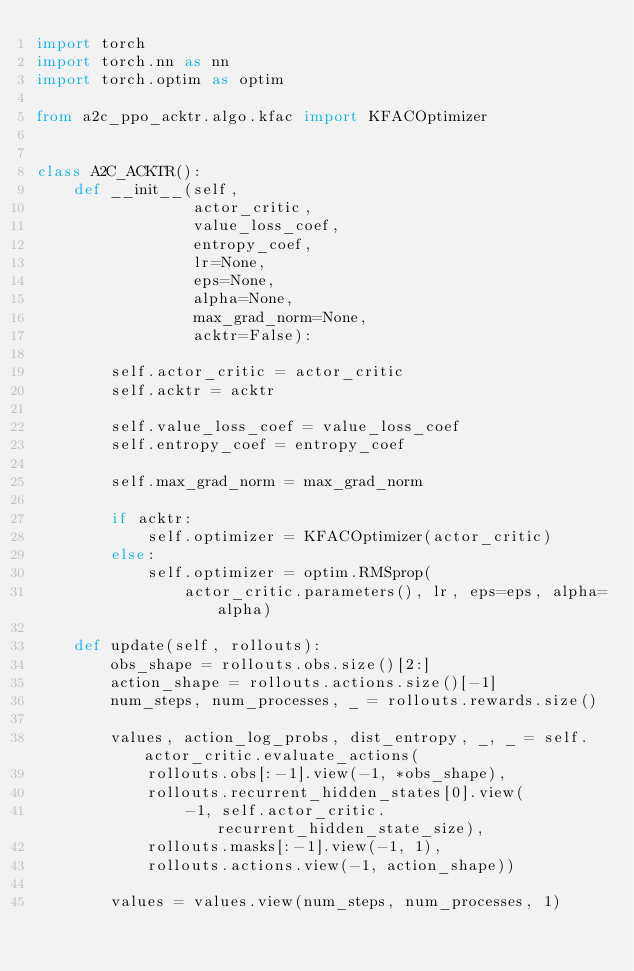<code> <loc_0><loc_0><loc_500><loc_500><_Python_>import torch
import torch.nn as nn
import torch.optim as optim

from a2c_ppo_acktr.algo.kfac import KFACOptimizer


class A2C_ACKTR():
    def __init__(self,
                 actor_critic,
                 value_loss_coef,
                 entropy_coef,
                 lr=None,
                 eps=None,
                 alpha=None,
                 max_grad_norm=None,
                 acktr=False):

        self.actor_critic = actor_critic
        self.acktr = acktr

        self.value_loss_coef = value_loss_coef
        self.entropy_coef = entropy_coef

        self.max_grad_norm = max_grad_norm

        if acktr:
            self.optimizer = KFACOptimizer(actor_critic)
        else:
            self.optimizer = optim.RMSprop(
                actor_critic.parameters(), lr, eps=eps, alpha=alpha)

    def update(self, rollouts):
        obs_shape = rollouts.obs.size()[2:]
        action_shape = rollouts.actions.size()[-1]
        num_steps, num_processes, _ = rollouts.rewards.size()

        values, action_log_probs, dist_entropy, _, _ = self.actor_critic.evaluate_actions(
            rollouts.obs[:-1].view(-1, *obs_shape),
            rollouts.recurrent_hidden_states[0].view(
                -1, self.actor_critic.recurrent_hidden_state_size),
            rollouts.masks[:-1].view(-1, 1),
            rollouts.actions.view(-1, action_shape))

        values = values.view(num_steps, num_processes, 1)</code> 